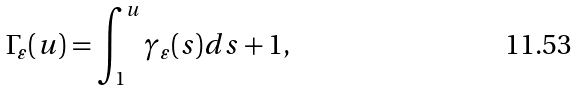<formula> <loc_0><loc_0><loc_500><loc_500>\Gamma _ { \varepsilon } ( u ) = \int _ { 1 } ^ { u } \gamma _ { \varepsilon } ( s ) d s + 1 ,</formula> 